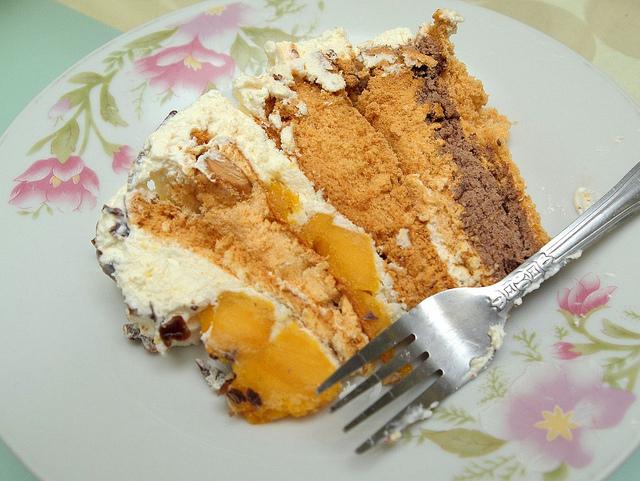Is this a desert item?
Keep it brief. Yes. What utensil is pictured?
Short answer required. Fork. What decoration is on the rim of the plate?
Keep it brief. Flowers. 